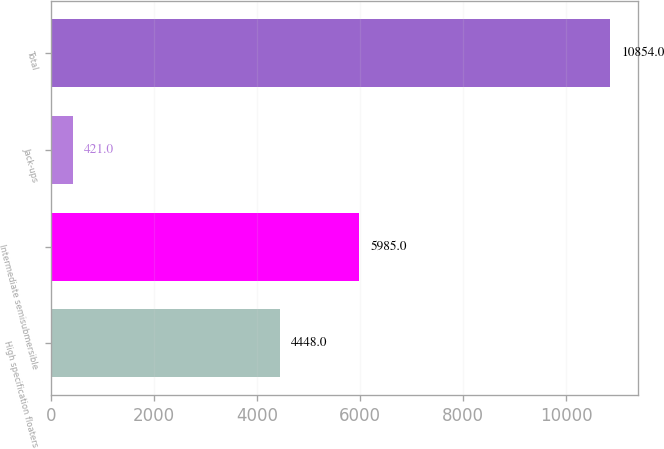<chart> <loc_0><loc_0><loc_500><loc_500><bar_chart><fcel>High specification floaters<fcel>Intermediate semisubmersible<fcel>Jack-ups<fcel>Total<nl><fcel>4448<fcel>5985<fcel>421<fcel>10854<nl></chart> 